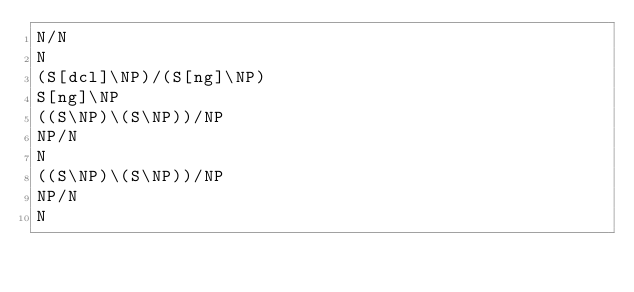<code> <loc_0><loc_0><loc_500><loc_500><_C_>N/N
N
(S[dcl]\NP)/(S[ng]\NP)
S[ng]\NP
((S\NP)\(S\NP))/NP
NP/N
N
((S\NP)\(S\NP))/NP
NP/N
N
</code> 